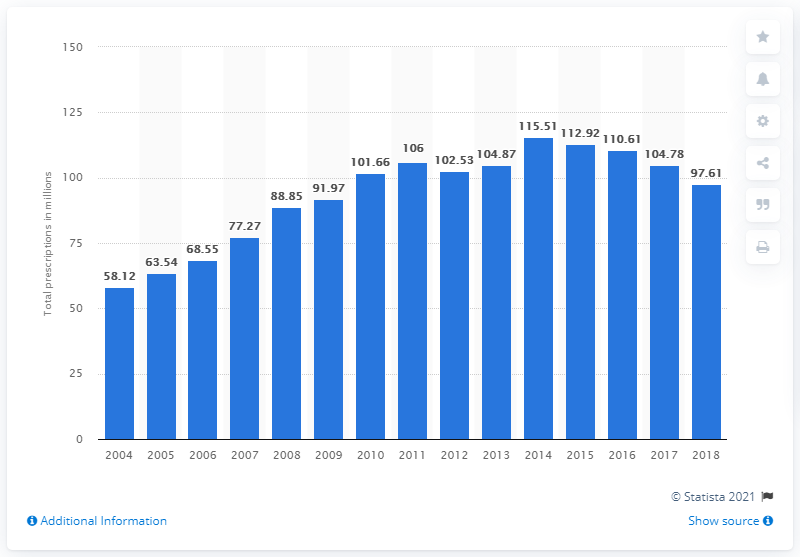Indicate a few pertinent items in this graphic. In 2010, there were a total of 97,614 prescriptions for the medication lisinopril. In 2008, a total of 88.85 prescriptions were written for the medication lisinopril. 